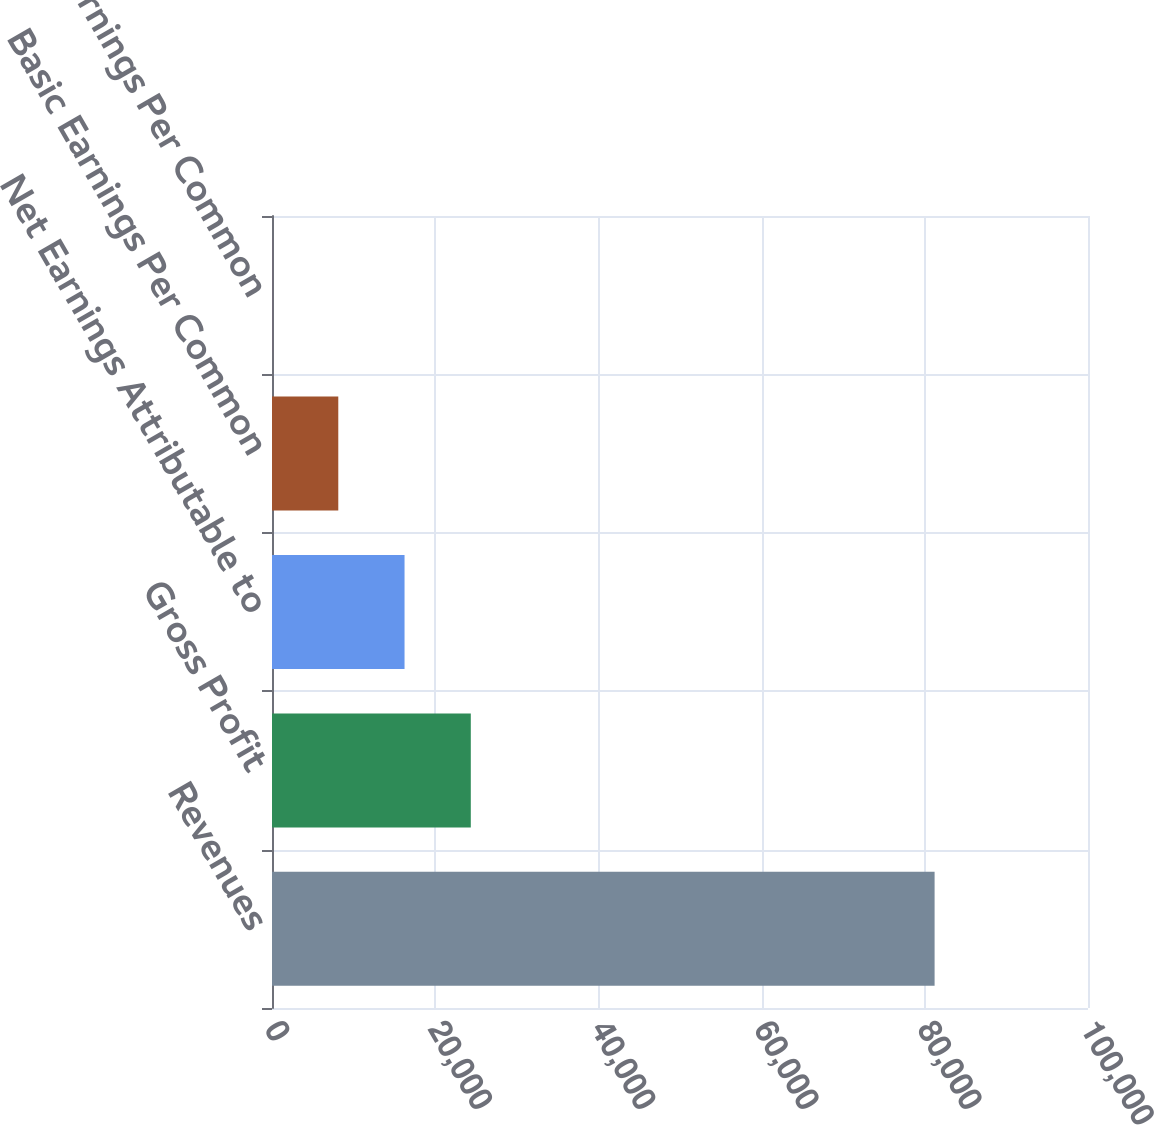<chart> <loc_0><loc_0><loc_500><loc_500><bar_chart><fcel>Revenues<fcel>Gross Profit<fcel>Net Earnings Attributable to<fcel>Basic Earnings Per Common<fcel>Diluted Earnings Per Common<nl><fcel>81201<fcel>24362.7<fcel>16243<fcel>8123.19<fcel>3.43<nl></chart> 